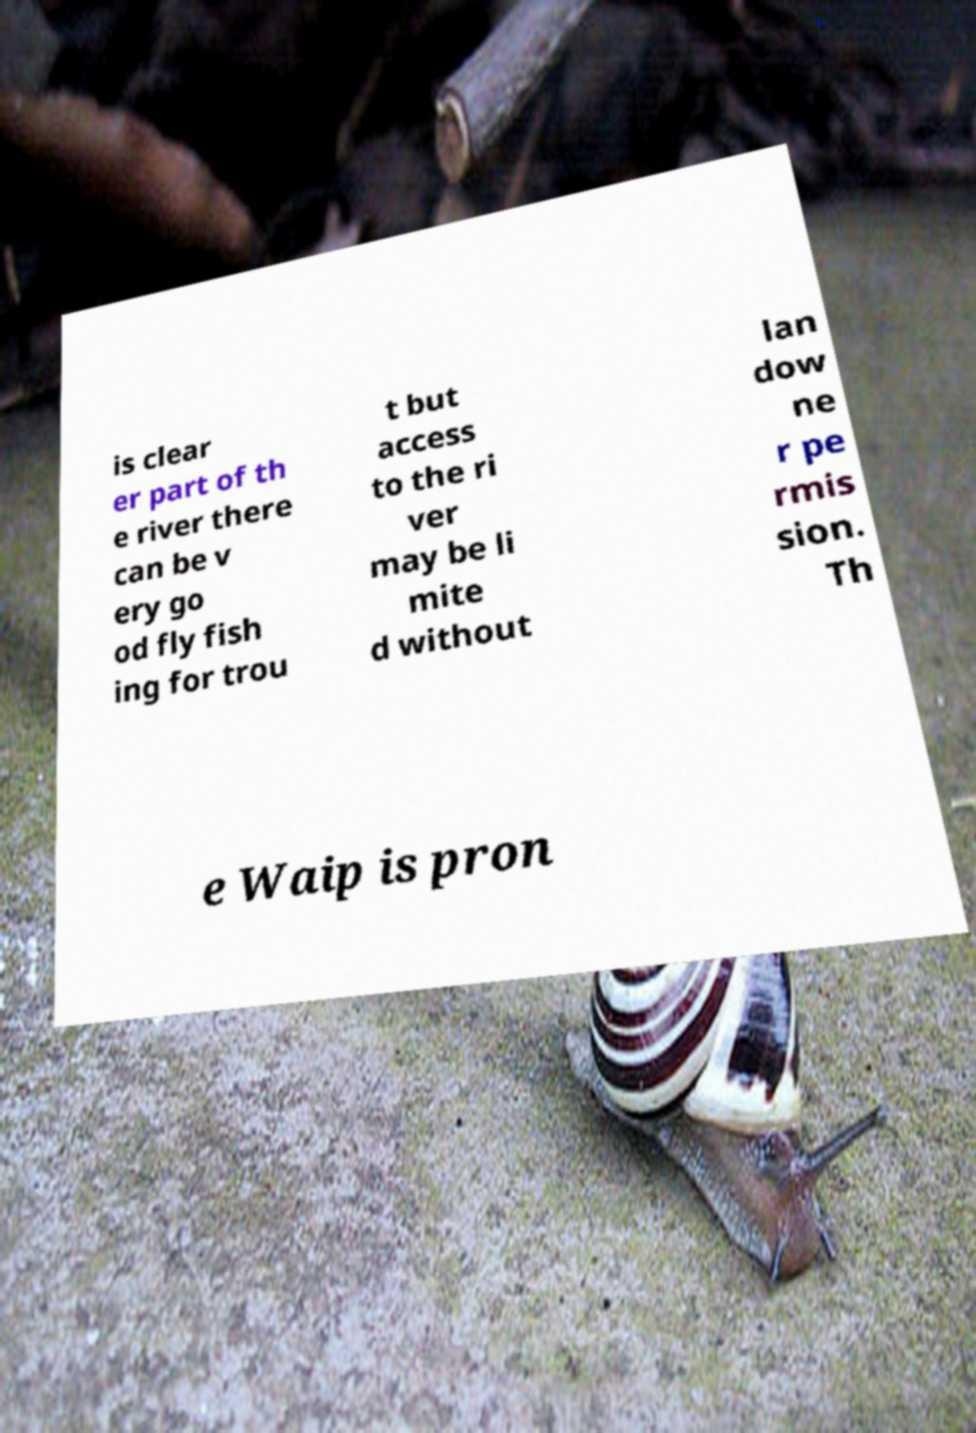What messages or text are displayed in this image? I need them in a readable, typed format. is clear er part of th e river there can be v ery go od fly fish ing for trou t but access to the ri ver may be li mite d without lan dow ne r pe rmis sion. Th e Waip is pron 